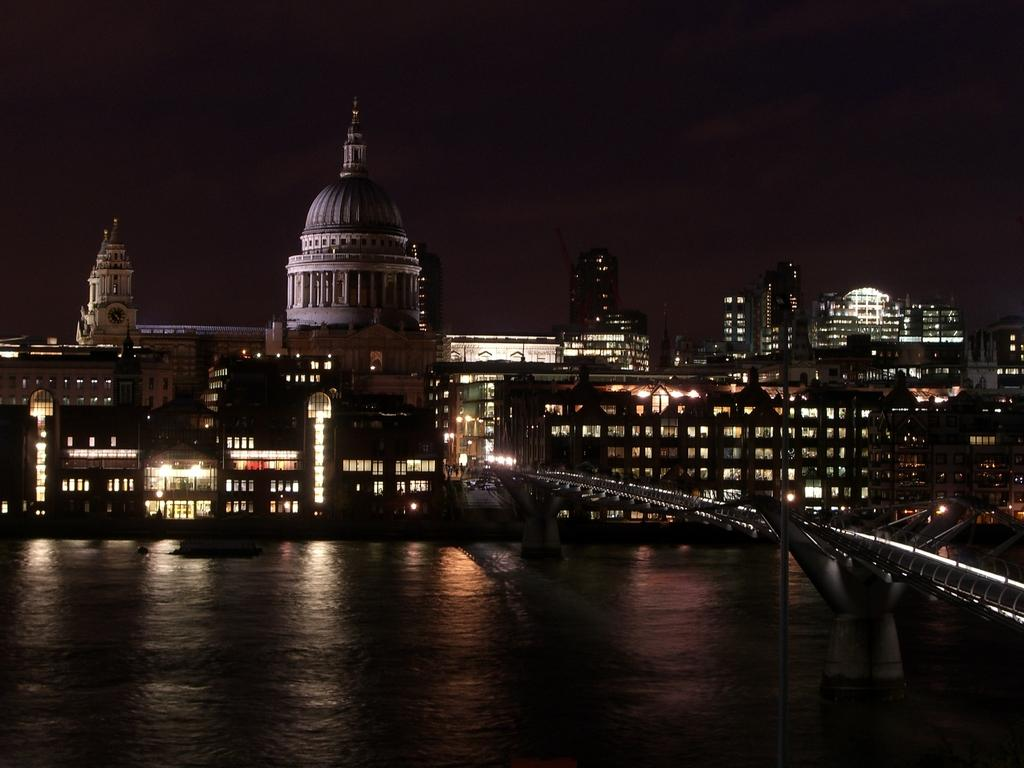What type of structures can be seen in the image? There are buildings in the image. What else is visible in the image besides the buildings? There are lights and a bridge in the image. Can you describe the bridge in the image? The bridge is over a river in the image. What part of the natural environment is visible in the image? The sky is visible in the image. What type of dress is the river wearing in the image? The river is not wearing a dress in the image; it is a natural body of water. 